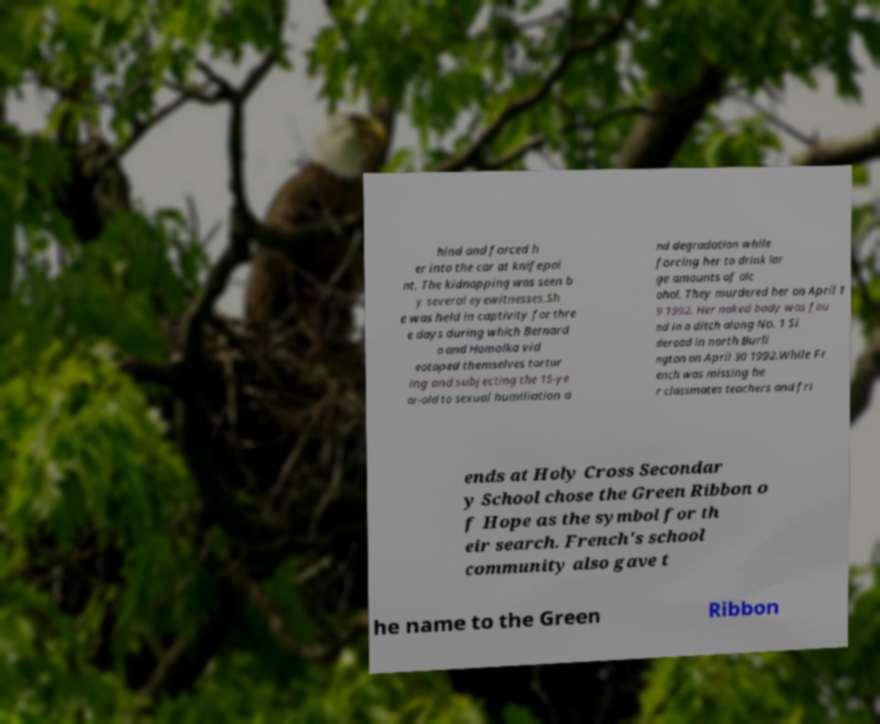I need the written content from this picture converted into text. Can you do that? hind and forced h er into the car at knifepoi nt. The kidnapping was seen b y several eyewitnesses.Sh e was held in captivity for thre e days during which Bernard o and Homolka vid eotaped themselves tortur ing and subjecting the 15-ye ar-old to sexual humiliation a nd degradation while forcing her to drink lar ge amounts of alc ohol. They murdered her on April 1 9 1992. Her naked body was fou nd in a ditch along No. 1 Si deroad in north Burli ngton on April 30 1992.While Fr ench was missing he r classmates teachers and fri ends at Holy Cross Secondar y School chose the Green Ribbon o f Hope as the symbol for th eir search. French's school community also gave t he name to the Green Ribbon 